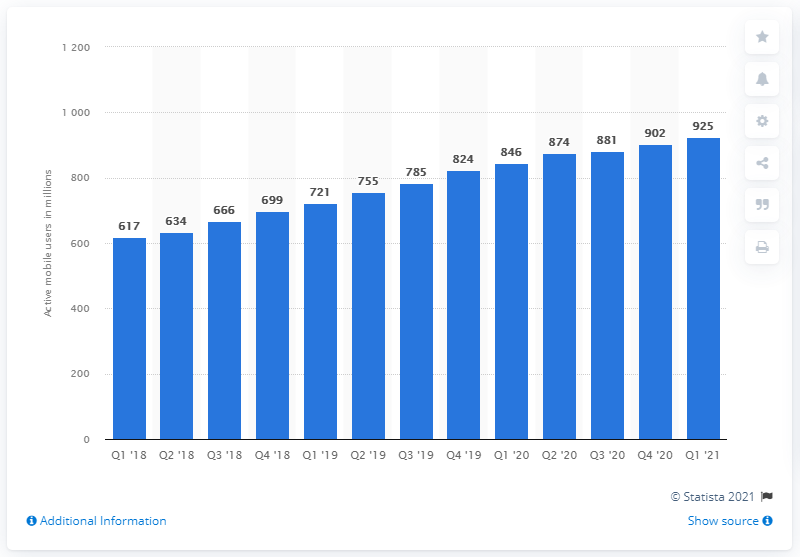Mention a couple of crucial points in this snapshot. In the first quarter of 2021, a total of 925 million monthly active users accessed Alibaba's Chinese e-commerce properties. 